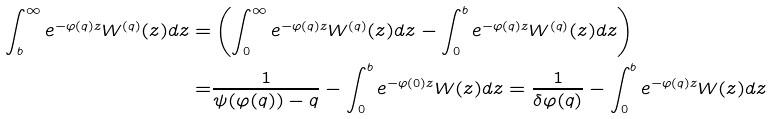<formula> <loc_0><loc_0><loc_500><loc_500>\int _ { b } ^ { \infty } e ^ { - \varphi ( q ) z } W ^ { ( q ) } ( z ) d z = & \left ( \int _ { 0 } ^ { \infty } e ^ { - \varphi ( q ) z } W ^ { ( q ) } ( z ) d z - \int _ { 0 } ^ { b } e ^ { - \varphi ( q ) z } W ^ { ( q ) } ( z ) d z \right ) \\ = & \frac { 1 } { \psi ( \varphi ( q ) ) - q } - \int _ { 0 } ^ { b } e ^ { - \varphi ( 0 ) z } W ( z ) d z = \frac { 1 } { \delta \varphi ( q ) } - \int _ { 0 } ^ { b } e ^ { - \varphi ( q ) z } W ( z ) d z</formula> 